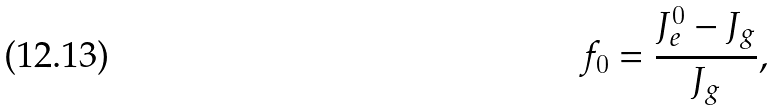Convert formula to latex. <formula><loc_0><loc_0><loc_500><loc_500>f _ { 0 } = \frac { J _ { e } ^ { 0 } - J _ { g } } { J _ { g } } ,</formula> 